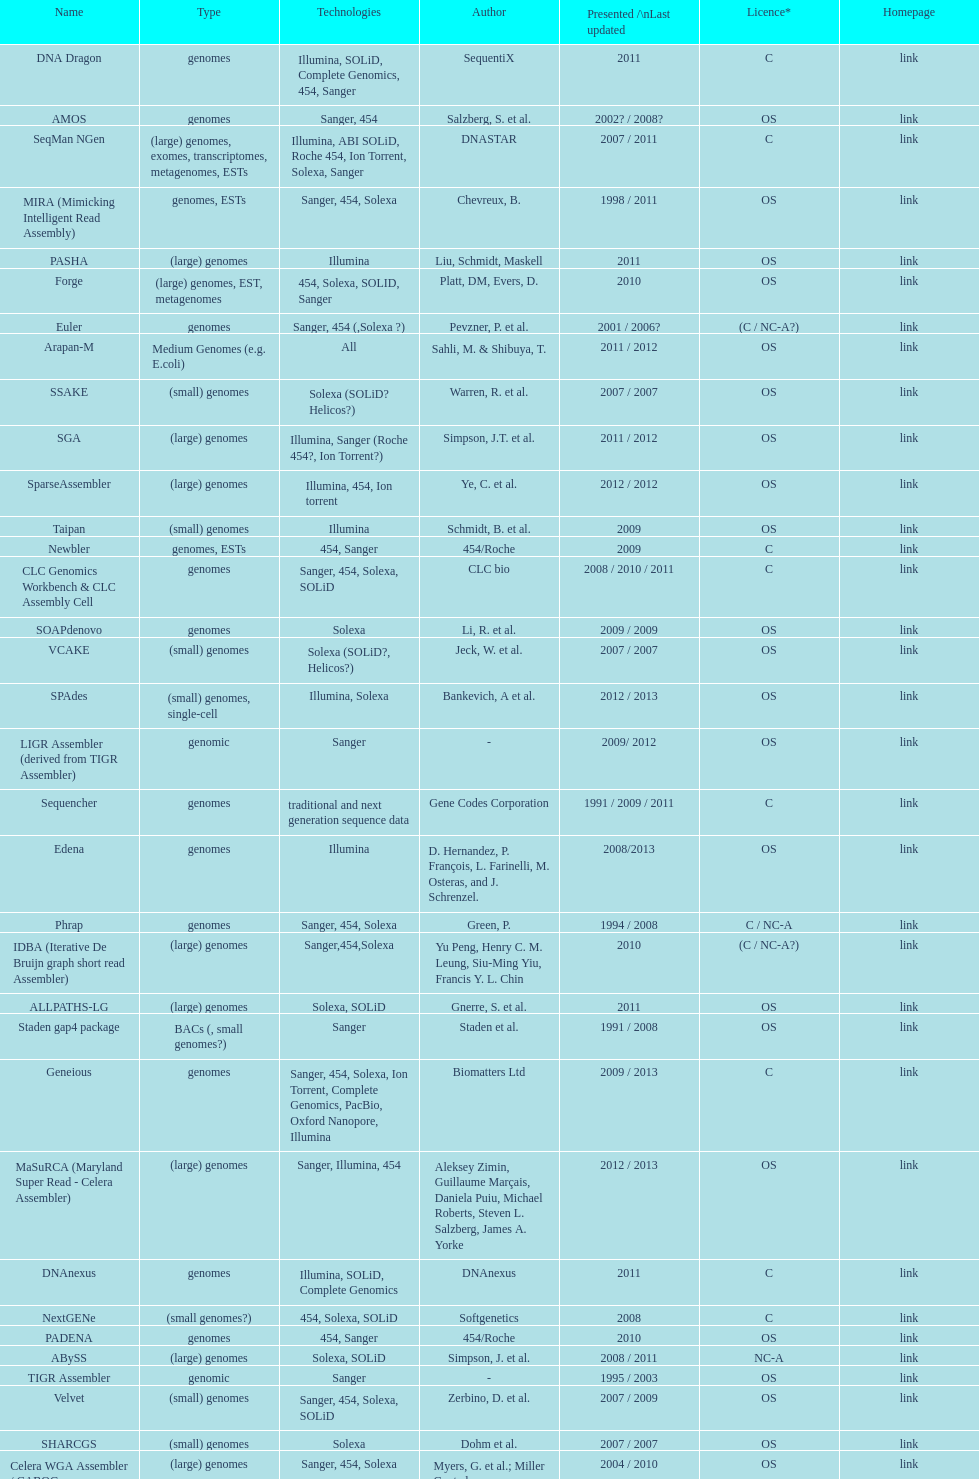How many are listed as "all" technologies? 2. 